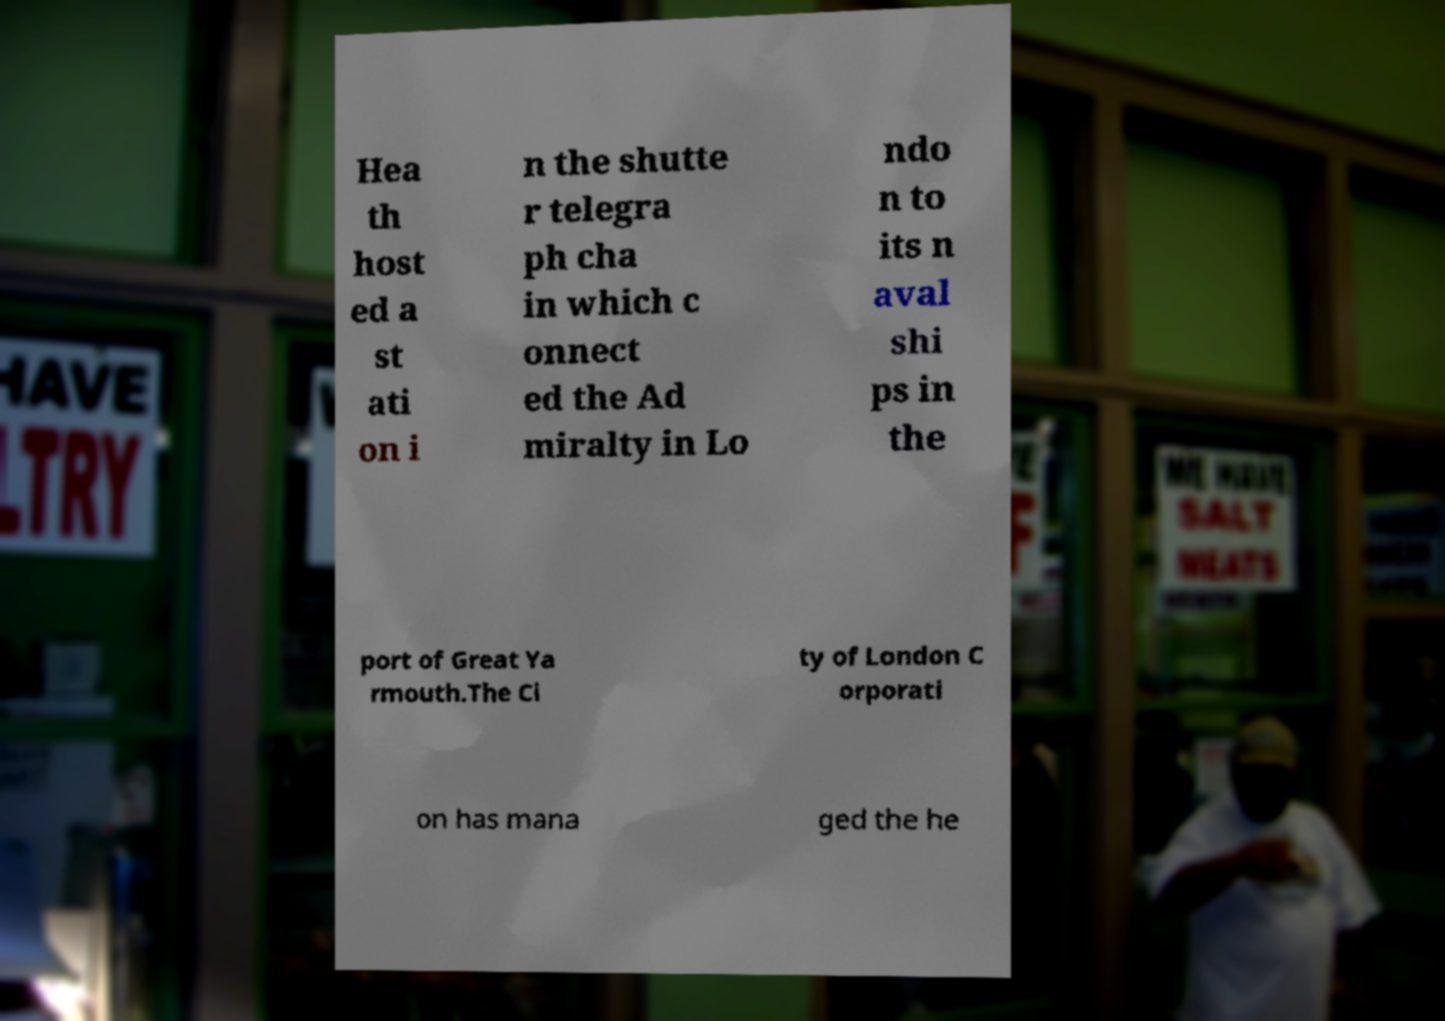Could you assist in decoding the text presented in this image and type it out clearly? Hea th host ed a st ati on i n the shutte r telegra ph cha in which c onnect ed the Ad miralty in Lo ndo n to its n aval shi ps in the port of Great Ya rmouth.The Ci ty of London C orporati on has mana ged the he 